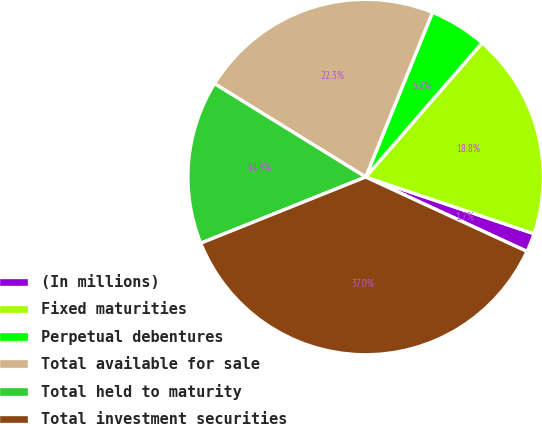Convert chart to OTSL. <chart><loc_0><loc_0><loc_500><loc_500><pie_chart><fcel>(In millions)<fcel>Fixed maturities<fcel>Perpetual debentures<fcel>Total available for sale<fcel>Total held to maturity<fcel>Total investment securities<nl><fcel>1.71%<fcel>18.79%<fcel>5.24%<fcel>22.33%<fcel>14.88%<fcel>37.05%<nl></chart> 